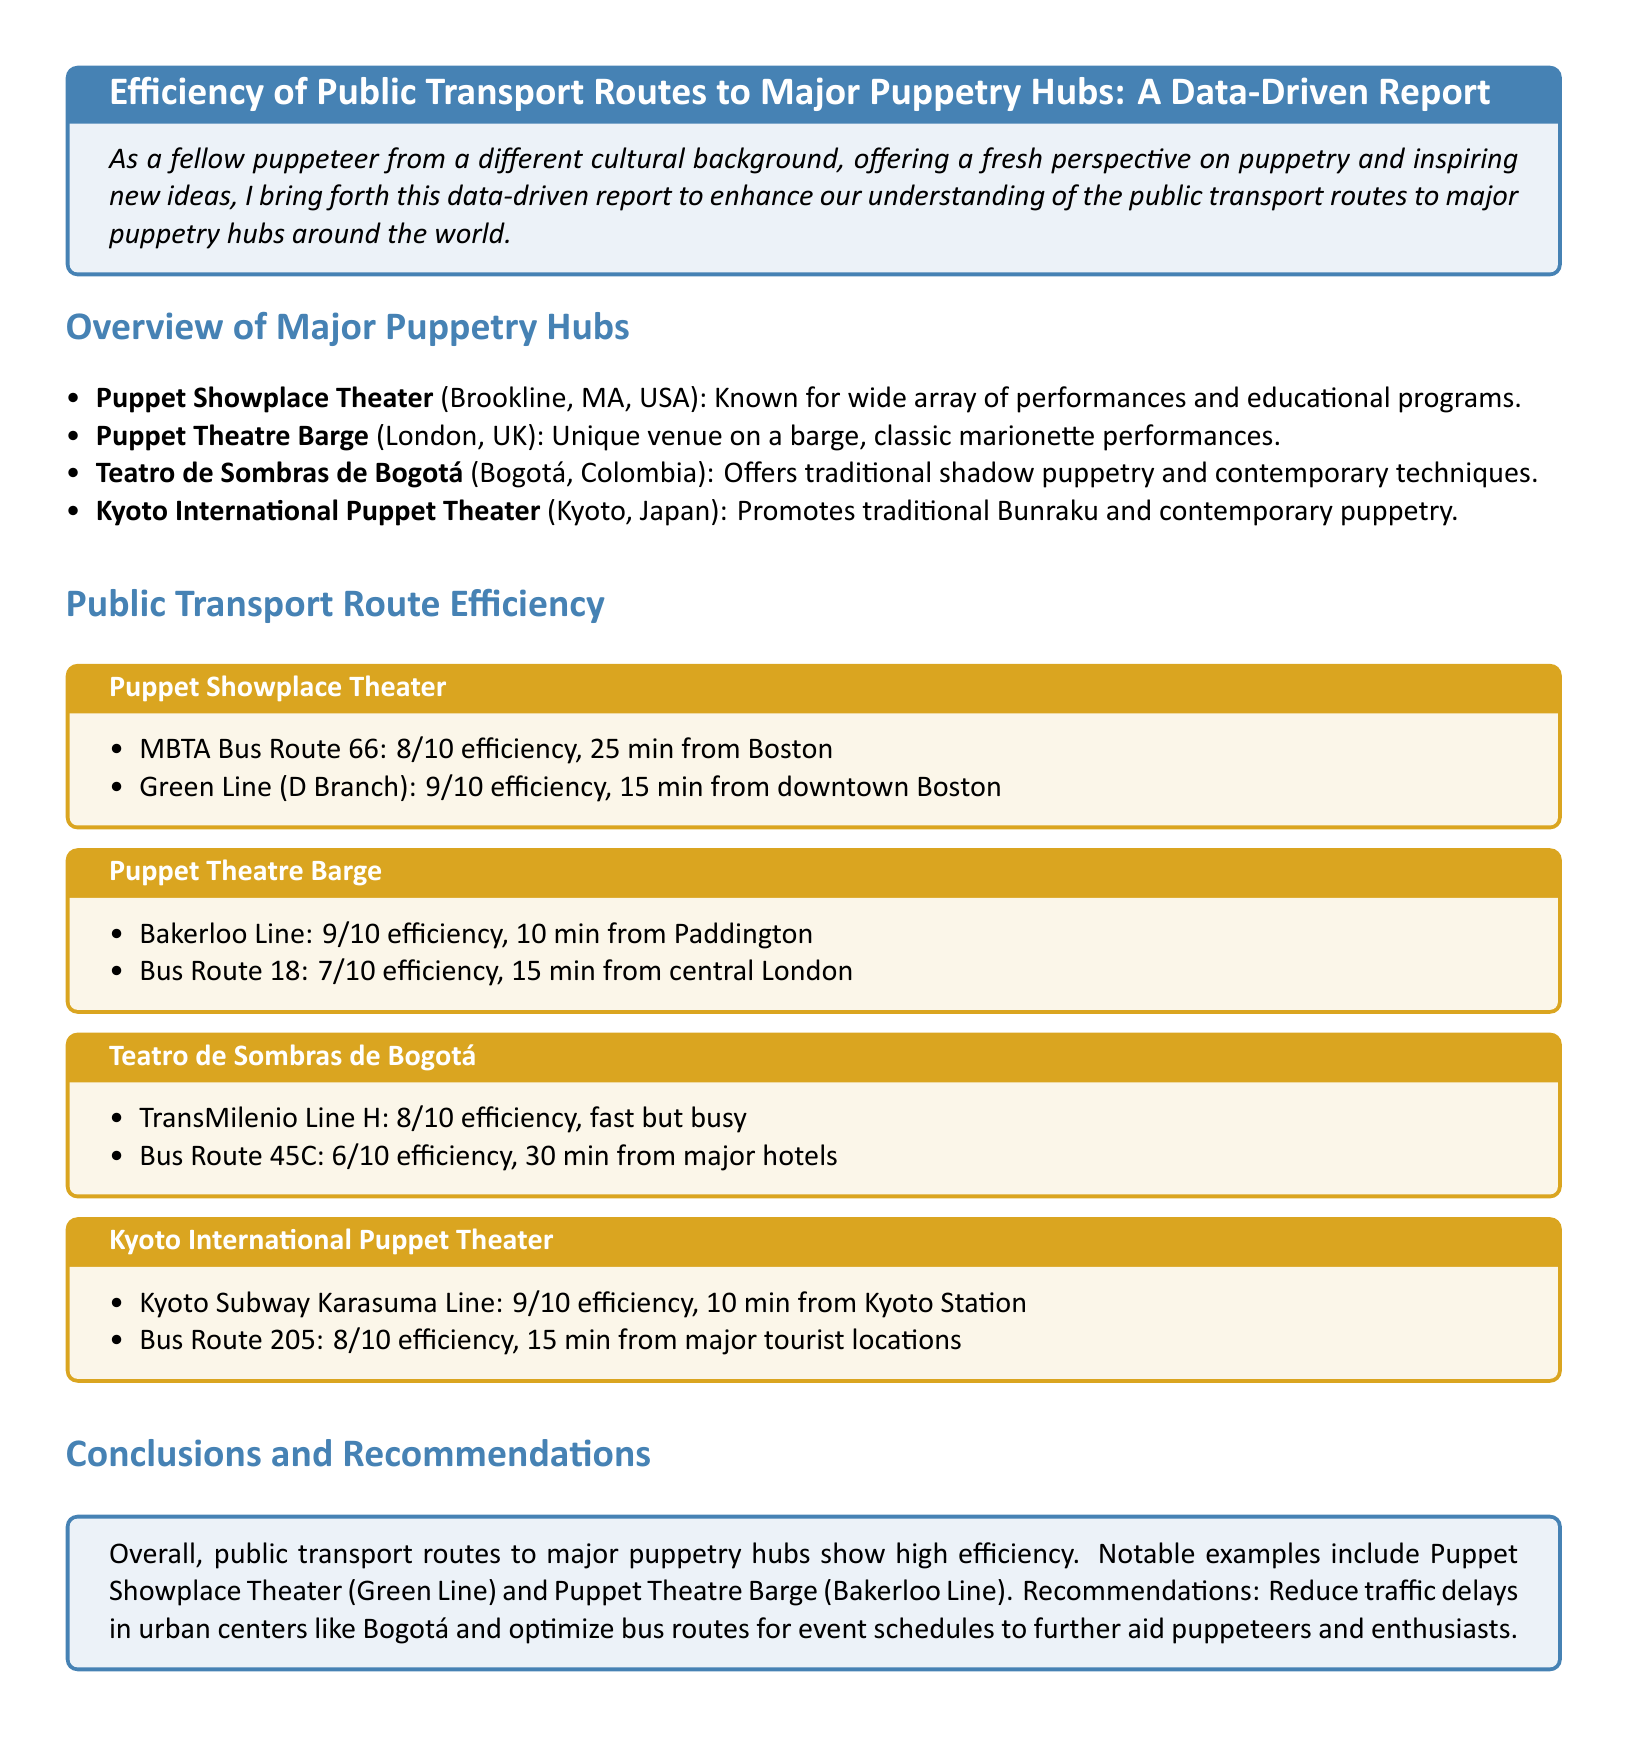What is the efficiency rating for the Green Line to Puppet Showplace Theater? The efficiency rating for the Green Line is found in the Public Transport Route Efficiency section, which states it is 9/10.
Answer: 9/10 What is the travel time of MBTA Bus Route 66 from Boston to Puppet Showplace Theater? The travel time for MBTA Bus Route 66 is mentioned in the document as 25 minutes.
Answer: 25 min Which bus route has the lowest efficiency rating to Teatro de Sombras de Bogotá? The bus route with the lowest efficiency is stated in the report as Bus Route 45C, which has a rating of 6/10.
Answer: Bus Route 45C What is the major form of public transport leading to Puppet Theatre Barge? The major form of public transport is detailed in the report and is identified as the Bakerloo Line, which is a subway line.
Answer: Bakerloo Line How many minutes does it take via bus Route 205 to reach Kyoto International Puppet Theater? The bus Route 205 travel time is specified as 15 minutes in the corresponding section of the report.
Answer: 15 min Which puppetry hub mentioned has the highest rated public transport route efficiency? The Puppetry hub with the highest rated efficiency mentioned is Puppet Showplace Theater, with an efficiency of 9/10 for the Green Line.
Answer: Puppet Showplace Theater What is the public transport efficiency rating for TransMilenio Line H to Teatro de Sombras de Bogotá? The Public Transport Route Efficiency section indicates that TransMilenio Line H has a rating of 8/10.
Answer: 8/10 What recommendation is made for Bogotá in relation to traffic delays? The report recommends reducing traffic delays in urban centers such as Bogotá to aid puppeteers and enthusiasts.
Answer: Reduce traffic delays 